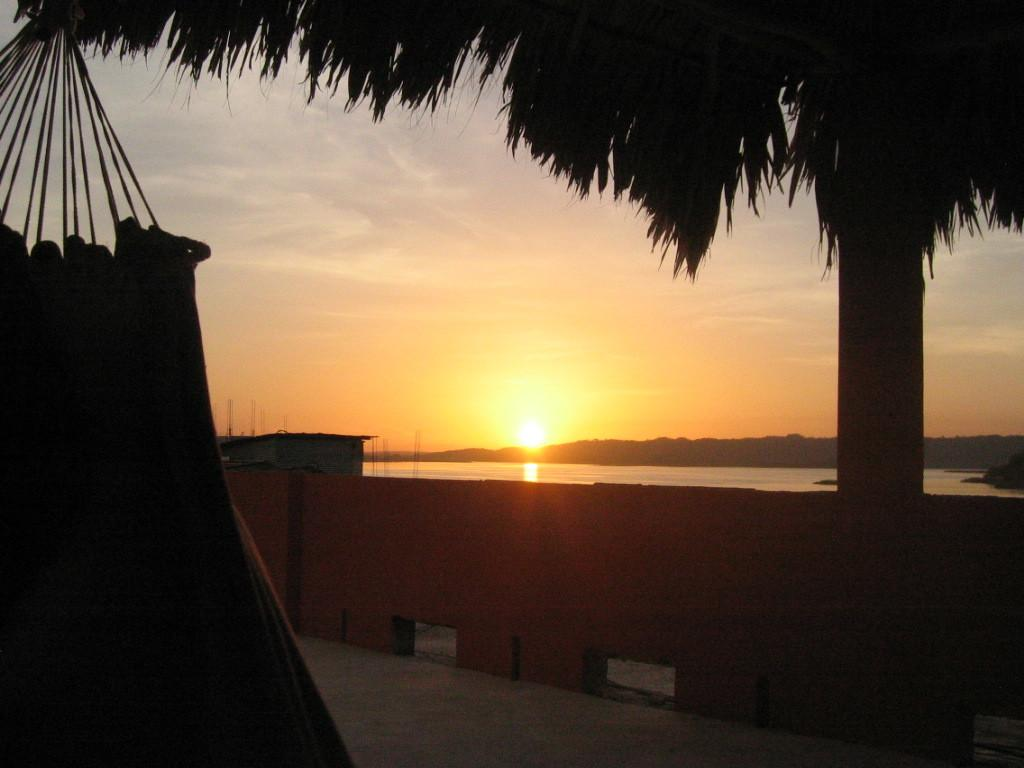What type of plant can be seen in the image? There is a tree in the image. What is hanging on the tree? There is a cloth hanged on the tree. What type of structure can be seen in the image? There is a wall and a shed in the image. What natural feature is visible in the image? There is water visible in the image, and mountains can also be seen. What is visible in the sky in the image? The sun is visible in the sky. Can you tell me how many dogs are playing with a cabbage in the image? There are no dogs or cabbage present in the image. What type of rifle is leaning against the shed in the image? There is no rifle present in the image; it only features a tree, a cloth, a wall, a shed, water, mountains, and the sun. 